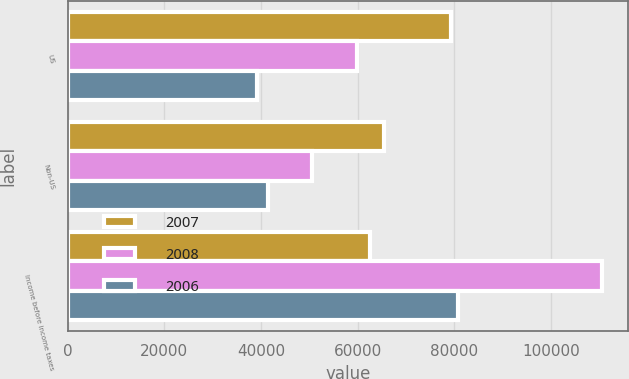Convert chart to OTSL. <chart><loc_0><loc_0><loc_500><loc_500><stacked_bar_chart><ecel><fcel>US<fcel>Non-US<fcel>Income before income taxes<nl><fcel>2007<fcel>79393<fcel>65348<fcel>62616<nl><fcel>2008<fcel>59884<fcel>50613<fcel>110497<nl><fcel>2006<fcel>39233<fcel>41428<fcel>80661<nl></chart> 